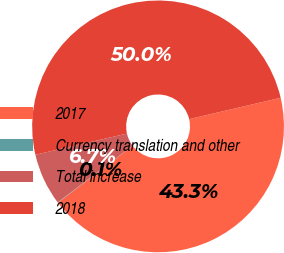<chart> <loc_0><loc_0><loc_500><loc_500><pie_chart><fcel>2017<fcel>Currency translation and other<fcel>Total increase<fcel>2018<nl><fcel>43.29%<fcel>0.05%<fcel>6.69%<fcel>49.97%<nl></chart> 